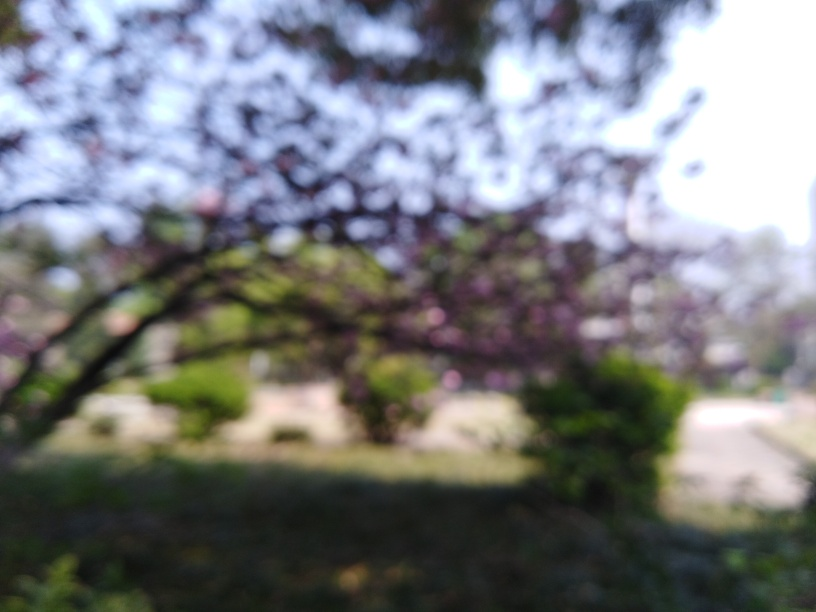What is the noise present in the background sky? Due to the blurred nature of the image, it's not possible to accurately determine the level of noise in the sky. However, based on the uniform coloring and lack of visible grain or distortion, one might infer that there is some noise present, though not significant enough to notably degrade the quality of the image. The response 'Some' corresponds with this assessment. 